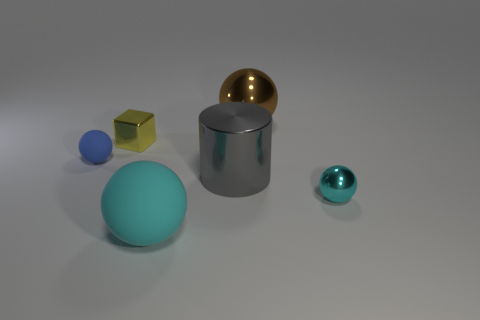Are there any other things that are the same shape as the tiny yellow object?
Your response must be concise. No. How many metal things are cyan spheres or purple cylinders?
Ensure brevity in your answer.  1. Does the small metal thing in front of the blue thing have the same shape as the blue thing that is left of the brown shiny sphere?
Make the answer very short. Yes. How many big rubber spheres are behind the tiny metal cube?
Your answer should be compact. 0. Is there a large brown object that has the same material as the small yellow thing?
Your response must be concise. Yes. There is a blue sphere that is the same size as the yellow shiny object; what is its material?
Your answer should be very brief. Rubber. Does the tiny blue ball have the same material as the big cyan sphere?
Keep it short and to the point. Yes. What number of things are gray cylinders or big gray rubber blocks?
Your answer should be very brief. 1. What is the shape of the matte thing that is right of the yellow shiny block?
Your answer should be very brief. Sphere. What color is the small object that is made of the same material as the big cyan sphere?
Your response must be concise. Blue. 